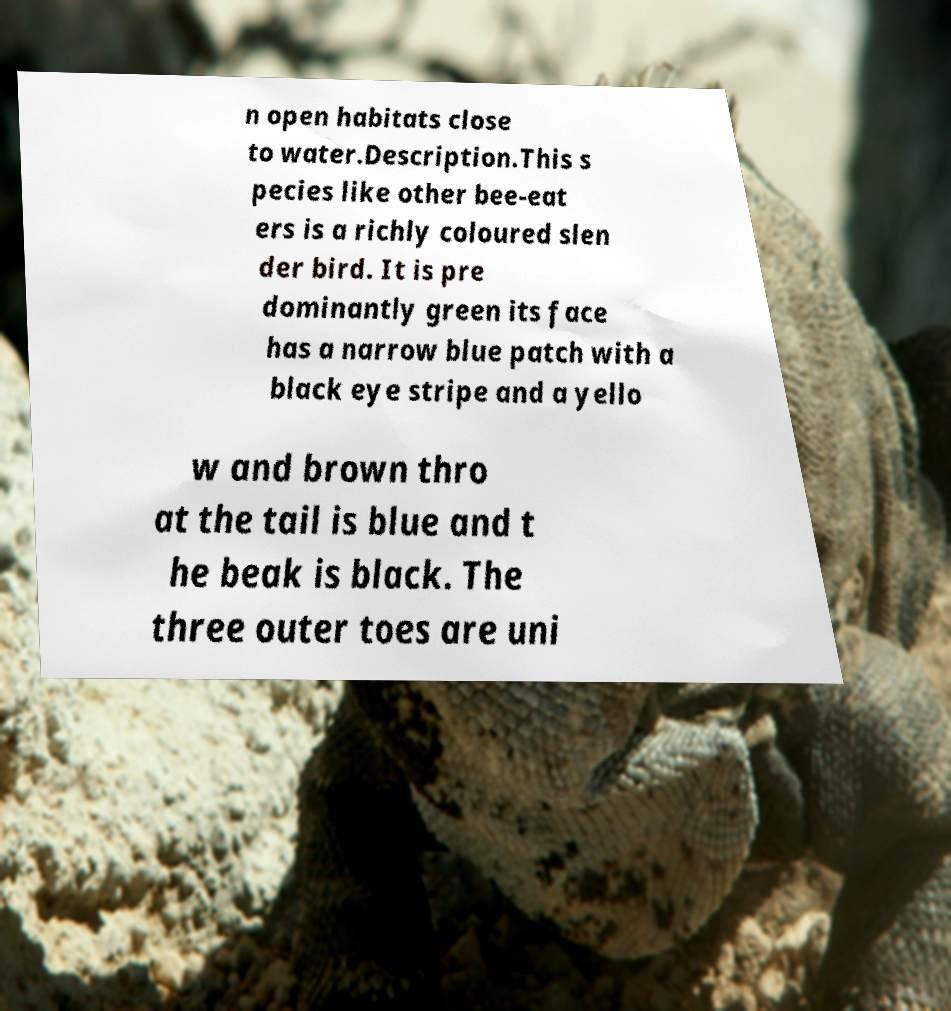Could you assist in decoding the text presented in this image and type it out clearly? n open habitats close to water.Description.This s pecies like other bee-eat ers is a richly coloured slen der bird. It is pre dominantly green its face has a narrow blue patch with a black eye stripe and a yello w and brown thro at the tail is blue and t he beak is black. The three outer toes are uni 